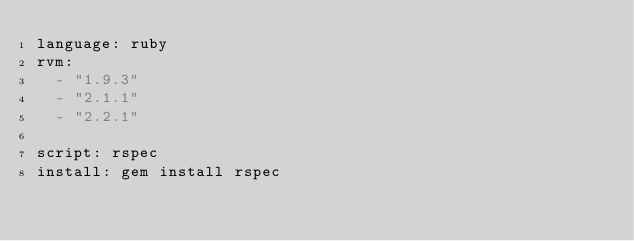Convert code to text. <code><loc_0><loc_0><loc_500><loc_500><_YAML_>language: ruby
rvm:
  - "1.9.3"
  - "2.1.1"
  - "2.2.1"

script: rspec
install: gem install rspec
</code> 